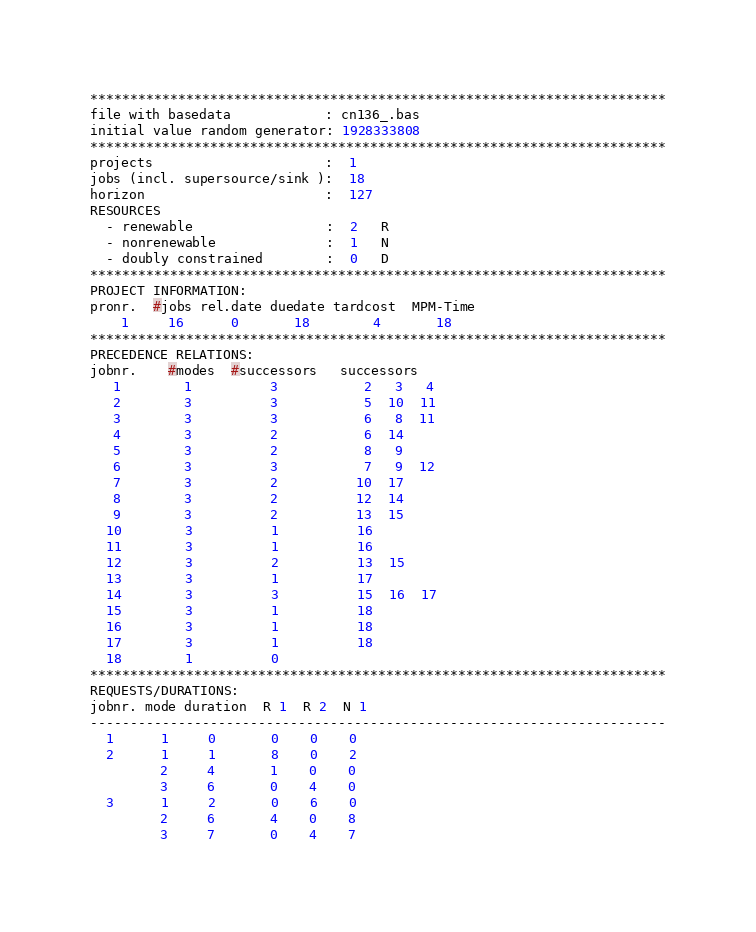Convert code to text. <code><loc_0><loc_0><loc_500><loc_500><_ObjectiveC_>************************************************************************
file with basedata            : cn136_.bas
initial value random generator: 1928333808
************************************************************************
projects                      :  1
jobs (incl. supersource/sink ):  18
horizon                       :  127
RESOURCES
  - renewable                 :  2   R
  - nonrenewable              :  1   N
  - doubly constrained        :  0   D
************************************************************************
PROJECT INFORMATION:
pronr.  #jobs rel.date duedate tardcost  MPM-Time
    1     16      0       18        4       18
************************************************************************
PRECEDENCE RELATIONS:
jobnr.    #modes  #successors   successors
   1        1          3           2   3   4
   2        3          3           5  10  11
   3        3          3           6   8  11
   4        3          2           6  14
   5        3          2           8   9
   6        3          3           7   9  12
   7        3          2          10  17
   8        3          2          12  14
   9        3          2          13  15
  10        3          1          16
  11        3          1          16
  12        3          2          13  15
  13        3          1          17
  14        3          3          15  16  17
  15        3          1          18
  16        3          1          18
  17        3          1          18
  18        1          0        
************************************************************************
REQUESTS/DURATIONS:
jobnr. mode duration  R 1  R 2  N 1
------------------------------------------------------------------------
  1      1     0       0    0    0
  2      1     1       8    0    2
         2     4       1    0    0
         3     6       0    4    0
  3      1     2       0    6    0
         2     6       4    0    8
         3     7       0    4    7</code> 